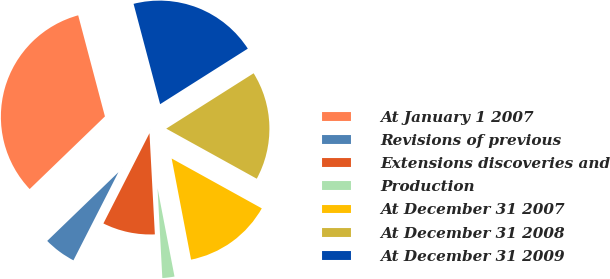Convert chart. <chart><loc_0><loc_0><loc_500><loc_500><pie_chart><fcel>At January 1 2007<fcel>Revisions of previous<fcel>Extensions discoveries and<fcel>Production<fcel>At December 31 2007<fcel>At December 31 2008<fcel>At December 31 2009<nl><fcel>33.1%<fcel>5.27%<fcel>8.36%<fcel>2.17%<fcel>13.94%<fcel>17.03%<fcel>20.13%<nl></chart> 